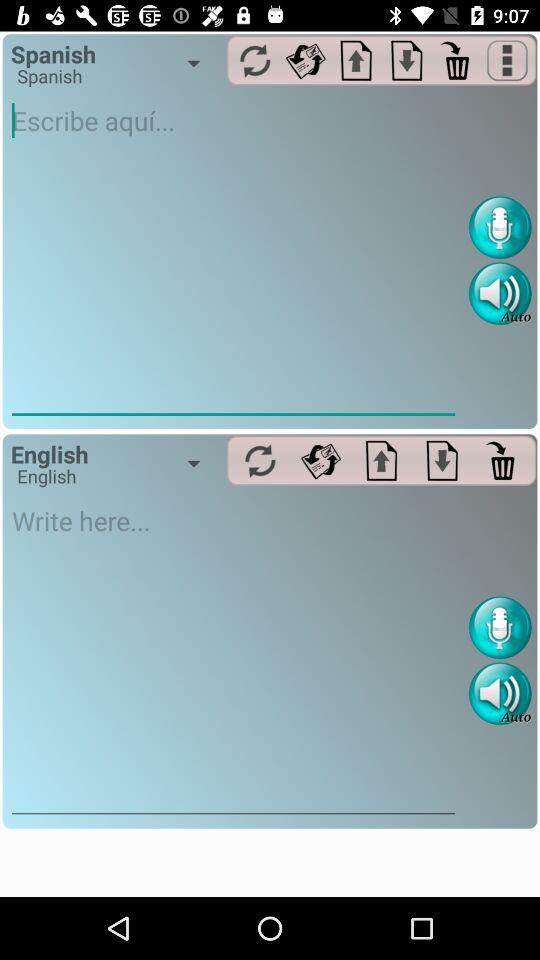Which of the languages is selected? The selected languages are Spanish and English. 